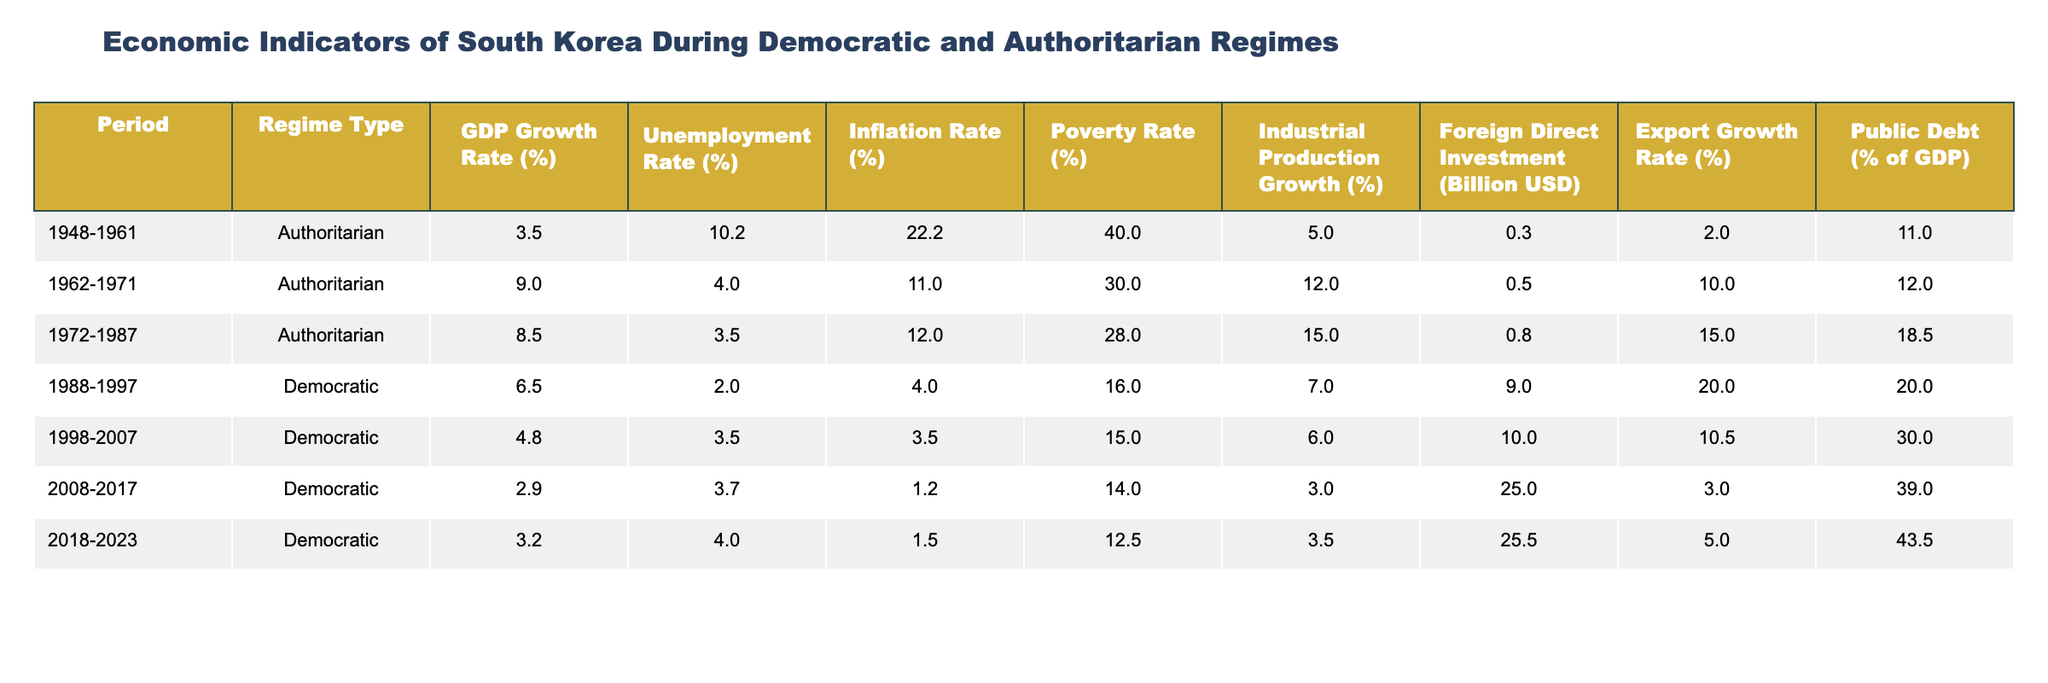What is the GDP growth rate during the period 1972-1987? The GDP growth rate during the period 1972-1987, which falls under the Authoritarian regime, is listed as 8.5%.
Answer: 8.5% What was the unemployment rate in South Korea under the Democratic regime from 1988 to 1997? The table shows that the unemployment rate during the Democratic regime from 1988 to 1997 is 2.0%.
Answer: 2.0% Which regime type had the highest Inflation Rate? Looking at the table, the Authoritarian regime from 1948 to 1961 had the highest Inflation Rate at 22.2%.
Answer: Authoritarian What is the average poverty rate during the Democratic regimes from 1988 to 2023? The poverty rates for the Democratic regimes are 16.0%, 15.0%, 14.0%, and 12.5%. Adding them gives 57.5%, and averaging them results in 57.5% / 4 = 14.375%.
Answer: 14.375% Was the Foreign Direct Investment higher in the Democratic regime from 2008 to 2017 than in the Authoritarian regime from 1962 to 1971? The Foreign Direct Investment during the Democratic regime from 2008 to 2017 is 25.0 billion USD, while it was only 0.5 billion USD during the Authoritarian regime from 1962 to 1971. Therefore, yes, it was higher.
Answer: Yes What is the difference in Public Debt as a percentage of GDP between the Democratic regime of 2008-2017 and the Authoritarian regime of 1972-1987? The Public Debt for the Democratic regime of 2008-2017 is 39.0%, and for the Authoritarian regime from 1972-1987 it is 18.5%. The difference is 39.0% - 18.5% = 20.5%.
Answer: 20.5% During which regime did the highest Export Growth Rate occur, and what was its value? The highest Export Growth Rate occurred during the Authoritarian regime from 1972 to 1987, with a value of 15.0%.
Answer: Authoritarian, 15.0% What is the trend in Industrial Production Growth from the Authoritarian regime to the Democratic regime starting from 1988? Looking at the data, the Industrial Production Growth rates showed a decline from 15.0% (1972-1987, Authoritarian) to 7.0% (1988-1997, Democratic) and further decreased to 3.0% by 2008-2017 (Democratic).
Answer: Declining Which period had the lowest unemployment rate? The period with the lowest unemployment rate is from 1988 to 1997 during the Democratic regime, with a rate of 2.0%.
Answer: 2.0% What was the Inflation Rate in the time frame of 2008-2017? The Inflation Rate during the Democratic regime from 2008-2017 is 1.2%, as shown in the table.
Answer: 1.2% 